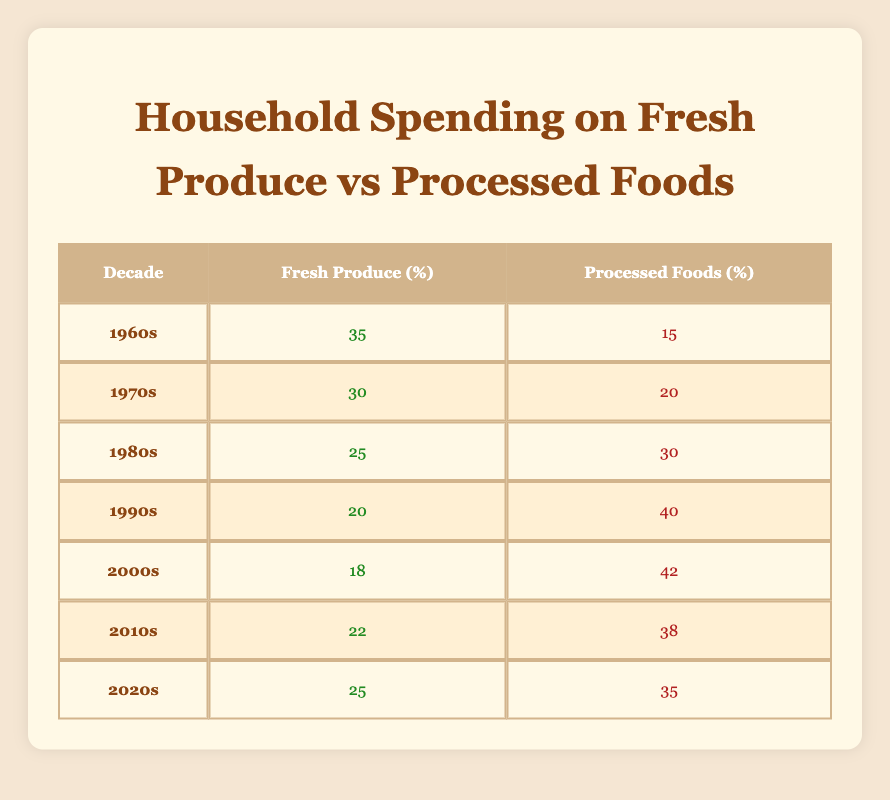Which decade had the highest household spending on fresh produce? Looking at the values in the table, the highest percentage for fresh produce is 35% in the 1960s.
Answer: 1960s In the 1980s, what was the household spending on processed foods? The table shows that household spending on processed foods in the 1980s was 30%.
Answer: 30 What is the difference in spending on fresh produce between the 1960s and the 2000s? The table indicates that spending on fresh produce was 35% in the 1960s and 18% in the 2000s. The difference is 35% - 18% = 17%.
Answer: 17% Was household spending on fresh produce lower than that on processed foods in 1990s? In the 1990s, spending on fresh produce was 20% and on processed foods was 40%. Thus, the spending on fresh produce was indeed lower.
Answer: Yes What is the average household spending on fresh produce from the 2010s to 2020s? The values for fresh produce from 2010s (22%) and 2020s (25%) are summed: 22% + 25% = 47%. Then we find the average: 47% / 2 = 23.5%.
Answer: 23.5 In which decades did household spending on processed foods exceed 30%? Reviewing the table, we see that in the 1980s (30%), 1990s (40%), and 2000s (42%), spending on processed foods was either equal to or exceeded 30%.
Answer: 1980s, 1990s, 2000s What was the trend of spending on fresh produce over the decades? The spending on fresh produce decreased from 35% in the 1960s to 18% in the 2000s, with a slight increase to 25% in the 2020s. Overall, there was a decline through the decades until the 2000s.
Answer: Decreasing with a slight increase in the 2020s Is it true that the spending on processed foods was highest in the 1990s compared to all other decades? Yes, the table shows that the spending on processed foods reached its peak at 40% in the 1990s, which is higher than all other decades listed.
Answer: Yes 